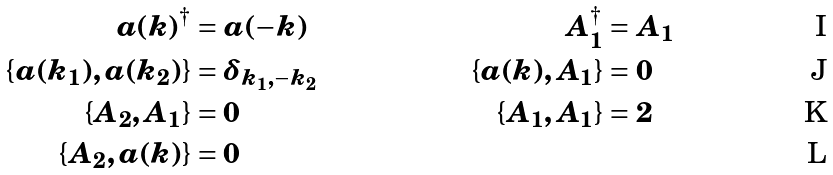<formula> <loc_0><loc_0><loc_500><loc_500>a ( k ) ^ { \dagger } & = a ( - k ) & A _ { 1 } ^ { \dagger } & = A _ { 1 } \\ \{ a ( k _ { 1 } ) , a ( k _ { 2 } ) \} & = \delta _ { k _ { 1 } , - k _ { 2 } } & \{ a ( k ) , A _ { 1 } \} & = 0 \\ \{ A _ { 2 } , A _ { 1 } \} & = 0 & \{ A _ { 1 } , A _ { 1 } \} & = 2 \\ \{ A _ { 2 } , a ( k ) \} & = 0 &</formula> 